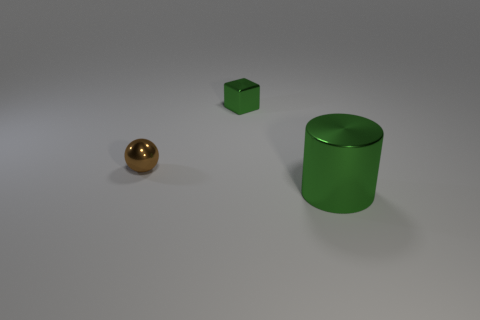Add 1 small objects. How many objects exist? 4 Subtract all spheres. How many objects are left? 2 Subtract all large blue things. Subtract all green cylinders. How many objects are left? 2 Add 1 small green objects. How many small green objects are left? 2 Add 3 gray balls. How many gray balls exist? 3 Subtract 0 brown blocks. How many objects are left? 3 